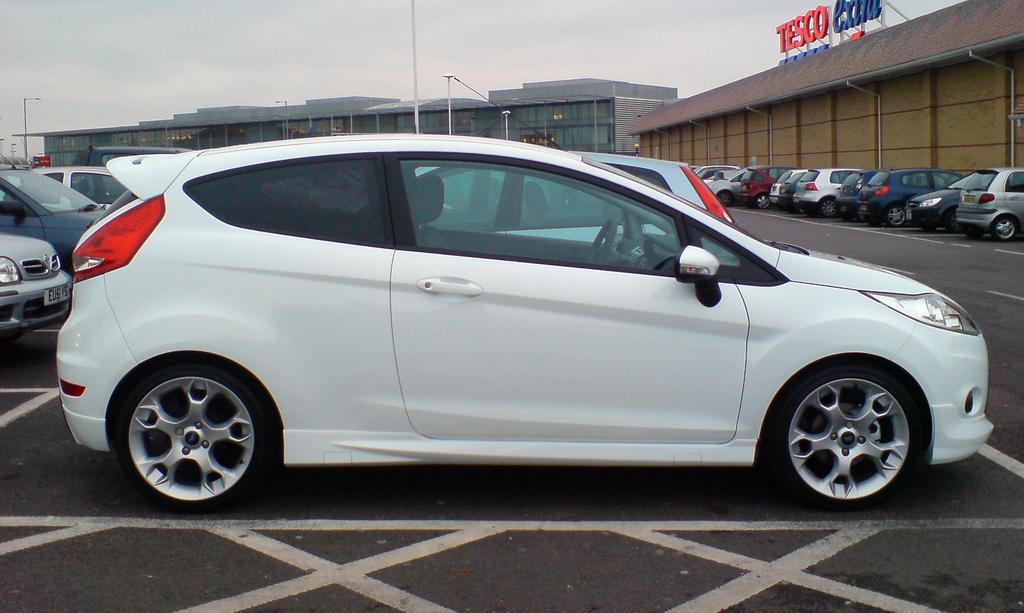Describe this image in one or two sentences. In this image few vehicles are on the road. Behind there are few street lights. Background there are few buildings. Right side there is a building having some text on it. Top of the image there is sky. 